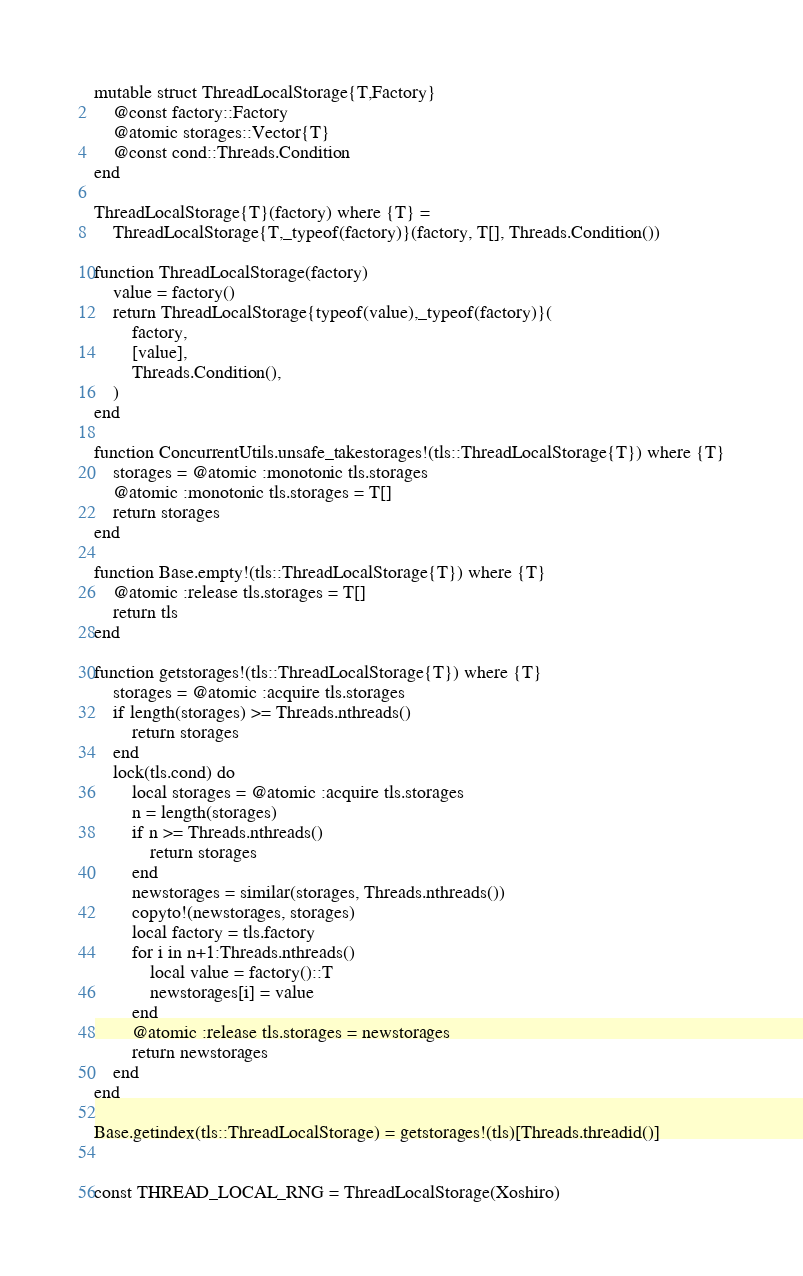Convert code to text. <code><loc_0><loc_0><loc_500><loc_500><_Julia_>mutable struct ThreadLocalStorage{T,Factory}
    @const factory::Factory
    @atomic storages::Vector{T}
    @const cond::Threads.Condition
end

ThreadLocalStorage{T}(factory) where {T} =
    ThreadLocalStorage{T,_typeof(factory)}(factory, T[], Threads.Condition())

function ThreadLocalStorage(factory)
    value = factory()
    return ThreadLocalStorage{typeof(value),_typeof(factory)}(
        factory,
        [value],
        Threads.Condition(),
    )
end

function ConcurrentUtils.unsafe_takestorages!(tls::ThreadLocalStorage{T}) where {T}
    storages = @atomic :monotonic tls.storages
    @atomic :monotonic tls.storages = T[]
    return storages
end

function Base.empty!(tls::ThreadLocalStorage{T}) where {T}
    @atomic :release tls.storages = T[]
    return tls
end

function getstorages!(tls::ThreadLocalStorage{T}) where {T}
    storages = @atomic :acquire tls.storages
    if length(storages) >= Threads.nthreads()
        return storages
    end
    lock(tls.cond) do
        local storages = @atomic :acquire tls.storages
        n = length(storages)
        if n >= Threads.nthreads()
            return storages
        end
        newstorages = similar(storages, Threads.nthreads())
        copyto!(newstorages, storages)
        local factory = tls.factory
        for i in n+1:Threads.nthreads()
            local value = factory()::T
            newstorages[i] = value
        end
        @atomic :release tls.storages = newstorages
        return newstorages
    end
end

Base.getindex(tls::ThreadLocalStorage) = getstorages!(tls)[Threads.threadid()]


const THREAD_LOCAL_RNG = ThreadLocalStorage(Xoshiro)
</code> 